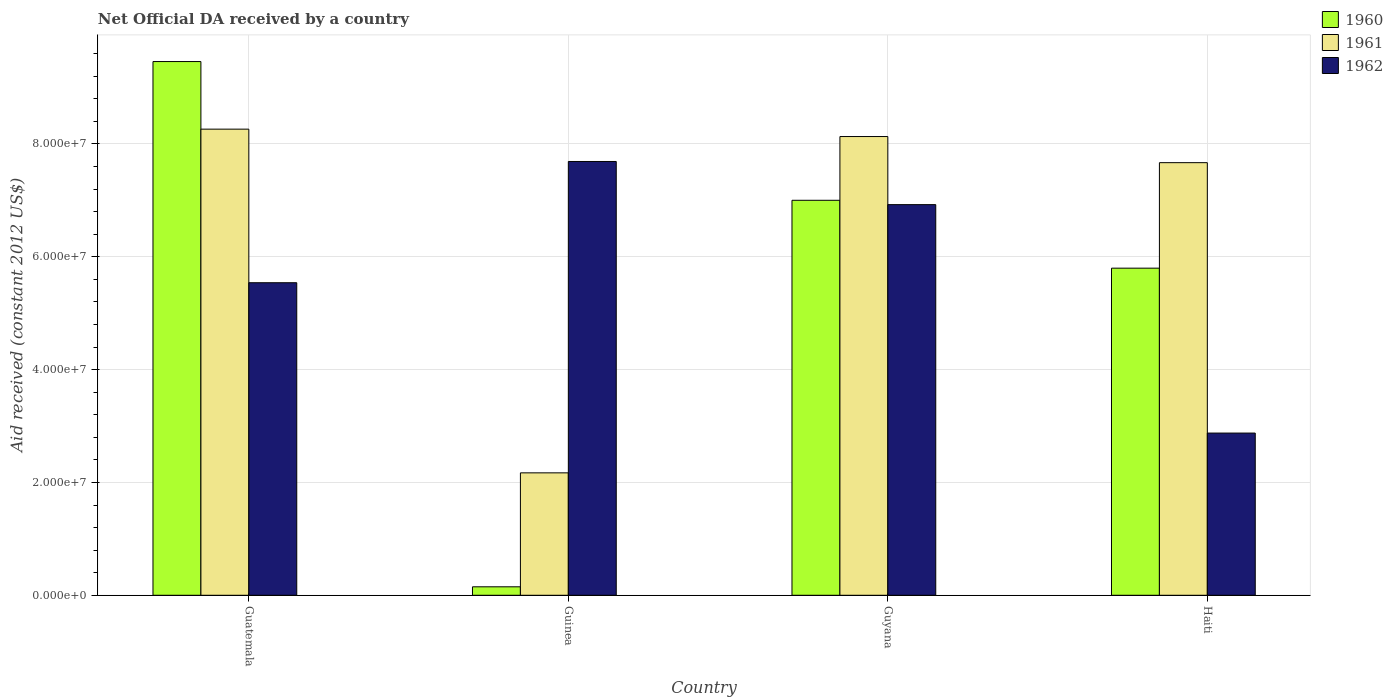How many different coloured bars are there?
Your response must be concise. 3. Are the number of bars per tick equal to the number of legend labels?
Offer a terse response. Yes. Are the number of bars on each tick of the X-axis equal?
Provide a short and direct response. Yes. What is the label of the 2nd group of bars from the left?
Offer a very short reply. Guinea. In how many cases, is the number of bars for a given country not equal to the number of legend labels?
Provide a short and direct response. 0. What is the net official development assistance aid received in 1960 in Guyana?
Your answer should be compact. 7.00e+07. Across all countries, what is the maximum net official development assistance aid received in 1962?
Provide a succinct answer. 7.69e+07. Across all countries, what is the minimum net official development assistance aid received in 1960?
Make the answer very short. 1.50e+06. In which country was the net official development assistance aid received in 1960 maximum?
Your response must be concise. Guatemala. In which country was the net official development assistance aid received in 1960 minimum?
Provide a succinct answer. Guinea. What is the total net official development assistance aid received in 1962 in the graph?
Ensure brevity in your answer.  2.30e+08. What is the difference between the net official development assistance aid received in 1960 in Guatemala and that in Guyana?
Provide a short and direct response. 2.46e+07. What is the difference between the net official development assistance aid received in 1962 in Guyana and the net official development assistance aid received in 1960 in Guinea?
Your response must be concise. 6.77e+07. What is the average net official development assistance aid received in 1961 per country?
Ensure brevity in your answer.  6.56e+07. What is the difference between the net official development assistance aid received of/in 1960 and net official development assistance aid received of/in 1961 in Guinea?
Your answer should be compact. -2.02e+07. In how many countries, is the net official development assistance aid received in 1962 greater than 48000000 US$?
Keep it short and to the point. 3. What is the ratio of the net official development assistance aid received in 1962 in Guyana to that in Haiti?
Your answer should be very brief. 2.41. Is the net official development assistance aid received in 1961 in Guatemala less than that in Guyana?
Offer a very short reply. No. Is the difference between the net official development assistance aid received in 1960 in Guatemala and Guinea greater than the difference between the net official development assistance aid received in 1961 in Guatemala and Guinea?
Make the answer very short. Yes. What is the difference between the highest and the second highest net official development assistance aid received in 1960?
Your answer should be compact. 3.66e+07. What is the difference between the highest and the lowest net official development assistance aid received in 1962?
Ensure brevity in your answer.  4.81e+07. Is the sum of the net official development assistance aid received in 1960 in Guyana and Haiti greater than the maximum net official development assistance aid received in 1962 across all countries?
Provide a short and direct response. Yes. What does the 3rd bar from the right in Haiti represents?
Your answer should be very brief. 1960. Does the graph contain any zero values?
Give a very brief answer. No. How are the legend labels stacked?
Your answer should be very brief. Vertical. What is the title of the graph?
Ensure brevity in your answer.  Net Official DA received by a country. Does "1967" appear as one of the legend labels in the graph?
Provide a succinct answer. No. What is the label or title of the Y-axis?
Give a very brief answer. Aid received (constant 2012 US$). What is the Aid received (constant 2012 US$) in 1960 in Guatemala?
Keep it short and to the point. 9.46e+07. What is the Aid received (constant 2012 US$) in 1961 in Guatemala?
Ensure brevity in your answer.  8.26e+07. What is the Aid received (constant 2012 US$) in 1962 in Guatemala?
Keep it short and to the point. 5.54e+07. What is the Aid received (constant 2012 US$) in 1960 in Guinea?
Give a very brief answer. 1.50e+06. What is the Aid received (constant 2012 US$) in 1961 in Guinea?
Ensure brevity in your answer.  2.17e+07. What is the Aid received (constant 2012 US$) of 1962 in Guinea?
Make the answer very short. 7.69e+07. What is the Aid received (constant 2012 US$) of 1960 in Guyana?
Make the answer very short. 7.00e+07. What is the Aid received (constant 2012 US$) in 1961 in Guyana?
Provide a short and direct response. 8.13e+07. What is the Aid received (constant 2012 US$) of 1962 in Guyana?
Your answer should be compact. 6.92e+07. What is the Aid received (constant 2012 US$) in 1960 in Haiti?
Your response must be concise. 5.80e+07. What is the Aid received (constant 2012 US$) in 1961 in Haiti?
Provide a succinct answer. 7.67e+07. What is the Aid received (constant 2012 US$) in 1962 in Haiti?
Offer a very short reply. 2.88e+07. Across all countries, what is the maximum Aid received (constant 2012 US$) of 1960?
Keep it short and to the point. 9.46e+07. Across all countries, what is the maximum Aid received (constant 2012 US$) of 1961?
Your answer should be compact. 8.26e+07. Across all countries, what is the maximum Aid received (constant 2012 US$) of 1962?
Offer a terse response. 7.69e+07. Across all countries, what is the minimum Aid received (constant 2012 US$) in 1960?
Make the answer very short. 1.50e+06. Across all countries, what is the minimum Aid received (constant 2012 US$) of 1961?
Make the answer very short. 2.17e+07. Across all countries, what is the minimum Aid received (constant 2012 US$) in 1962?
Provide a short and direct response. 2.88e+07. What is the total Aid received (constant 2012 US$) in 1960 in the graph?
Ensure brevity in your answer.  2.24e+08. What is the total Aid received (constant 2012 US$) in 1961 in the graph?
Provide a succinct answer. 2.62e+08. What is the total Aid received (constant 2012 US$) of 1962 in the graph?
Provide a succinct answer. 2.30e+08. What is the difference between the Aid received (constant 2012 US$) of 1960 in Guatemala and that in Guinea?
Ensure brevity in your answer.  9.31e+07. What is the difference between the Aid received (constant 2012 US$) in 1961 in Guatemala and that in Guinea?
Ensure brevity in your answer.  6.09e+07. What is the difference between the Aid received (constant 2012 US$) in 1962 in Guatemala and that in Guinea?
Give a very brief answer. -2.15e+07. What is the difference between the Aid received (constant 2012 US$) in 1960 in Guatemala and that in Guyana?
Give a very brief answer. 2.46e+07. What is the difference between the Aid received (constant 2012 US$) in 1961 in Guatemala and that in Guyana?
Offer a very short reply. 1.31e+06. What is the difference between the Aid received (constant 2012 US$) of 1962 in Guatemala and that in Guyana?
Provide a succinct answer. -1.38e+07. What is the difference between the Aid received (constant 2012 US$) in 1960 in Guatemala and that in Haiti?
Give a very brief answer. 3.66e+07. What is the difference between the Aid received (constant 2012 US$) in 1961 in Guatemala and that in Haiti?
Offer a very short reply. 5.94e+06. What is the difference between the Aid received (constant 2012 US$) in 1962 in Guatemala and that in Haiti?
Keep it short and to the point. 2.66e+07. What is the difference between the Aid received (constant 2012 US$) in 1960 in Guinea and that in Guyana?
Provide a succinct answer. -6.85e+07. What is the difference between the Aid received (constant 2012 US$) in 1961 in Guinea and that in Guyana?
Your answer should be very brief. -5.96e+07. What is the difference between the Aid received (constant 2012 US$) in 1962 in Guinea and that in Guyana?
Offer a terse response. 7.65e+06. What is the difference between the Aid received (constant 2012 US$) of 1960 in Guinea and that in Haiti?
Provide a short and direct response. -5.65e+07. What is the difference between the Aid received (constant 2012 US$) of 1961 in Guinea and that in Haiti?
Your answer should be compact. -5.50e+07. What is the difference between the Aid received (constant 2012 US$) of 1962 in Guinea and that in Haiti?
Ensure brevity in your answer.  4.81e+07. What is the difference between the Aid received (constant 2012 US$) in 1960 in Guyana and that in Haiti?
Ensure brevity in your answer.  1.20e+07. What is the difference between the Aid received (constant 2012 US$) in 1961 in Guyana and that in Haiti?
Make the answer very short. 4.63e+06. What is the difference between the Aid received (constant 2012 US$) in 1962 in Guyana and that in Haiti?
Offer a very short reply. 4.05e+07. What is the difference between the Aid received (constant 2012 US$) in 1960 in Guatemala and the Aid received (constant 2012 US$) in 1961 in Guinea?
Give a very brief answer. 7.29e+07. What is the difference between the Aid received (constant 2012 US$) in 1960 in Guatemala and the Aid received (constant 2012 US$) in 1962 in Guinea?
Keep it short and to the point. 1.77e+07. What is the difference between the Aid received (constant 2012 US$) in 1961 in Guatemala and the Aid received (constant 2012 US$) in 1962 in Guinea?
Keep it short and to the point. 5.73e+06. What is the difference between the Aid received (constant 2012 US$) of 1960 in Guatemala and the Aid received (constant 2012 US$) of 1961 in Guyana?
Make the answer very short. 1.33e+07. What is the difference between the Aid received (constant 2012 US$) of 1960 in Guatemala and the Aid received (constant 2012 US$) of 1962 in Guyana?
Your answer should be compact. 2.54e+07. What is the difference between the Aid received (constant 2012 US$) in 1961 in Guatemala and the Aid received (constant 2012 US$) in 1962 in Guyana?
Give a very brief answer. 1.34e+07. What is the difference between the Aid received (constant 2012 US$) in 1960 in Guatemala and the Aid received (constant 2012 US$) in 1961 in Haiti?
Keep it short and to the point. 1.79e+07. What is the difference between the Aid received (constant 2012 US$) of 1960 in Guatemala and the Aid received (constant 2012 US$) of 1962 in Haiti?
Provide a succinct answer. 6.58e+07. What is the difference between the Aid received (constant 2012 US$) of 1961 in Guatemala and the Aid received (constant 2012 US$) of 1962 in Haiti?
Provide a short and direct response. 5.39e+07. What is the difference between the Aid received (constant 2012 US$) of 1960 in Guinea and the Aid received (constant 2012 US$) of 1961 in Guyana?
Your answer should be very brief. -7.98e+07. What is the difference between the Aid received (constant 2012 US$) of 1960 in Guinea and the Aid received (constant 2012 US$) of 1962 in Guyana?
Provide a short and direct response. -6.77e+07. What is the difference between the Aid received (constant 2012 US$) of 1961 in Guinea and the Aid received (constant 2012 US$) of 1962 in Guyana?
Keep it short and to the point. -4.75e+07. What is the difference between the Aid received (constant 2012 US$) of 1960 in Guinea and the Aid received (constant 2012 US$) of 1961 in Haiti?
Your answer should be compact. -7.52e+07. What is the difference between the Aid received (constant 2012 US$) of 1960 in Guinea and the Aid received (constant 2012 US$) of 1962 in Haiti?
Your answer should be compact. -2.72e+07. What is the difference between the Aid received (constant 2012 US$) of 1961 in Guinea and the Aid received (constant 2012 US$) of 1962 in Haiti?
Ensure brevity in your answer.  -7.05e+06. What is the difference between the Aid received (constant 2012 US$) in 1960 in Guyana and the Aid received (constant 2012 US$) in 1961 in Haiti?
Provide a succinct answer. -6.67e+06. What is the difference between the Aid received (constant 2012 US$) of 1960 in Guyana and the Aid received (constant 2012 US$) of 1962 in Haiti?
Provide a succinct answer. 4.13e+07. What is the difference between the Aid received (constant 2012 US$) of 1961 in Guyana and the Aid received (constant 2012 US$) of 1962 in Haiti?
Your answer should be compact. 5.26e+07. What is the average Aid received (constant 2012 US$) of 1960 per country?
Make the answer very short. 5.60e+07. What is the average Aid received (constant 2012 US$) in 1961 per country?
Keep it short and to the point. 6.56e+07. What is the average Aid received (constant 2012 US$) in 1962 per country?
Provide a succinct answer. 5.76e+07. What is the difference between the Aid received (constant 2012 US$) of 1960 and Aid received (constant 2012 US$) of 1961 in Guatemala?
Make the answer very short. 1.20e+07. What is the difference between the Aid received (constant 2012 US$) in 1960 and Aid received (constant 2012 US$) in 1962 in Guatemala?
Give a very brief answer. 3.92e+07. What is the difference between the Aid received (constant 2012 US$) in 1961 and Aid received (constant 2012 US$) in 1962 in Guatemala?
Keep it short and to the point. 2.72e+07. What is the difference between the Aid received (constant 2012 US$) in 1960 and Aid received (constant 2012 US$) in 1961 in Guinea?
Provide a succinct answer. -2.02e+07. What is the difference between the Aid received (constant 2012 US$) of 1960 and Aid received (constant 2012 US$) of 1962 in Guinea?
Your response must be concise. -7.54e+07. What is the difference between the Aid received (constant 2012 US$) of 1961 and Aid received (constant 2012 US$) of 1962 in Guinea?
Provide a short and direct response. -5.52e+07. What is the difference between the Aid received (constant 2012 US$) in 1960 and Aid received (constant 2012 US$) in 1961 in Guyana?
Ensure brevity in your answer.  -1.13e+07. What is the difference between the Aid received (constant 2012 US$) of 1960 and Aid received (constant 2012 US$) of 1962 in Guyana?
Give a very brief answer. 7.70e+05. What is the difference between the Aid received (constant 2012 US$) of 1961 and Aid received (constant 2012 US$) of 1962 in Guyana?
Your answer should be very brief. 1.21e+07. What is the difference between the Aid received (constant 2012 US$) of 1960 and Aid received (constant 2012 US$) of 1961 in Haiti?
Offer a terse response. -1.87e+07. What is the difference between the Aid received (constant 2012 US$) in 1960 and Aid received (constant 2012 US$) in 1962 in Haiti?
Keep it short and to the point. 2.92e+07. What is the difference between the Aid received (constant 2012 US$) of 1961 and Aid received (constant 2012 US$) of 1962 in Haiti?
Provide a short and direct response. 4.79e+07. What is the ratio of the Aid received (constant 2012 US$) of 1960 in Guatemala to that in Guinea?
Offer a terse response. 63.07. What is the ratio of the Aid received (constant 2012 US$) of 1961 in Guatemala to that in Guinea?
Provide a succinct answer. 3.81. What is the ratio of the Aid received (constant 2012 US$) of 1962 in Guatemala to that in Guinea?
Your response must be concise. 0.72. What is the ratio of the Aid received (constant 2012 US$) of 1960 in Guatemala to that in Guyana?
Offer a terse response. 1.35. What is the ratio of the Aid received (constant 2012 US$) in 1961 in Guatemala to that in Guyana?
Offer a terse response. 1.02. What is the ratio of the Aid received (constant 2012 US$) of 1962 in Guatemala to that in Guyana?
Provide a short and direct response. 0.8. What is the ratio of the Aid received (constant 2012 US$) in 1960 in Guatemala to that in Haiti?
Ensure brevity in your answer.  1.63. What is the ratio of the Aid received (constant 2012 US$) in 1961 in Guatemala to that in Haiti?
Your answer should be compact. 1.08. What is the ratio of the Aid received (constant 2012 US$) in 1962 in Guatemala to that in Haiti?
Make the answer very short. 1.93. What is the ratio of the Aid received (constant 2012 US$) in 1960 in Guinea to that in Guyana?
Offer a terse response. 0.02. What is the ratio of the Aid received (constant 2012 US$) of 1961 in Guinea to that in Guyana?
Offer a very short reply. 0.27. What is the ratio of the Aid received (constant 2012 US$) of 1962 in Guinea to that in Guyana?
Provide a succinct answer. 1.11. What is the ratio of the Aid received (constant 2012 US$) of 1960 in Guinea to that in Haiti?
Your answer should be compact. 0.03. What is the ratio of the Aid received (constant 2012 US$) in 1961 in Guinea to that in Haiti?
Offer a terse response. 0.28. What is the ratio of the Aid received (constant 2012 US$) in 1962 in Guinea to that in Haiti?
Your response must be concise. 2.67. What is the ratio of the Aid received (constant 2012 US$) of 1960 in Guyana to that in Haiti?
Your answer should be compact. 1.21. What is the ratio of the Aid received (constant 2012 US$) of 1961 in Guyana to that in Haiti?
Offer a very short reply. 1.06. What is the ratio of the Aid received (constant 2012 US$) of 1962 in Guyana to that in Haiti?
Your answer should be very brief. 2.41. What is the difference between the highest and the second highest Aid received (constant 2012 US$) in 1960?
Offer a terse response. 2.46e+07. What is the difference between the highest and the second highest Aid received (constant 2012 US$) of 1961?
Your response must be concise. 1.31e+06. What is the difference between the highest and the second highest Aid received (constant 2012 US$) in 1962?
Make the answer very short. 7.65e+06. What is the difference between the highest and the lowest Aid received (constant 2012 US$) in 1960?
Keep it short and to the point. 9.31e+07. What is the difference between the highest and the lowest Aid received (constant 2012 US$) of 1961?
Your response must be concise. 6.09e+07. What is the difference between the highest and the lowest Aid received (constant 2012 US$) in 1962?
Your answer should be very brief. 4.81e+07. 